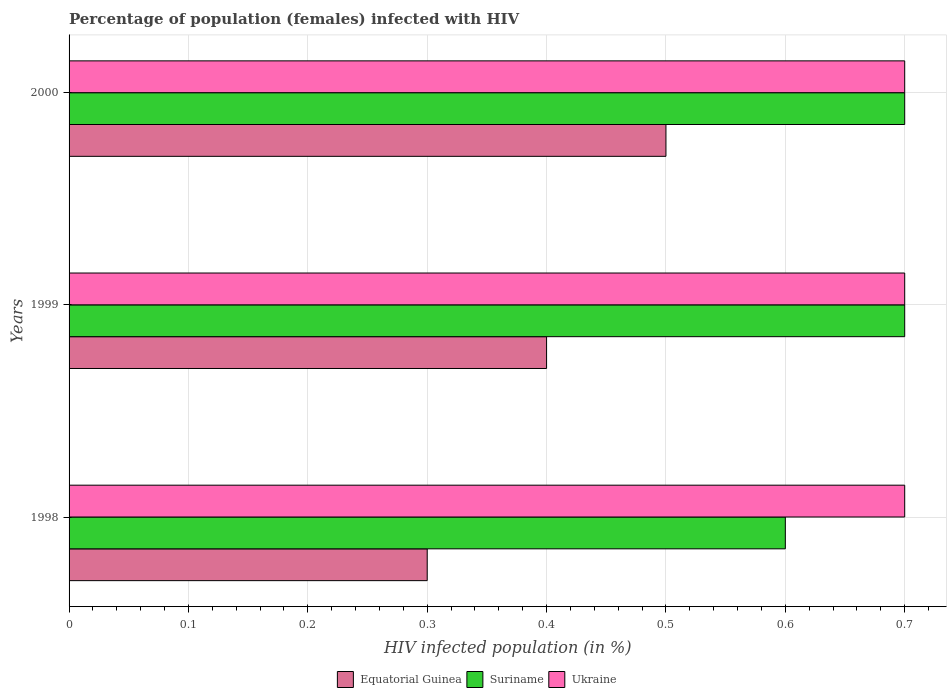How many different coloured bars are there?
Ensure brevity in your answer.  3. How many groups of bars are there?
Offer a very short reply. 3. Are the number of bars on each tick of the Y-axis equal?
Give a very brief answer. Yes. What is the label of the 1st group of bars from the top?
Your answer should be very brief. 2000. In how many cases, is the number of bars for a given year not equal to the number of legend labels?
Offer a very short reply. 0. What is the percentage of HIV infected female population in Ukraine in 2000?
Your answer should be compact. 0.7. Across all years, what is the maximum percentage of HIV infected female population in Ukraine?
Provide a short and direct response. 0.7. In which year was the percentage of HIV infected female population in Equatorial Guinea maximum?
Make the answer very short. 2000. What is the total percentage of HIV infected female population in Suriname in the graph?
Your answer should be compact. 2. What is the difference between the percentage of HIV infected female population in Equatorial Guinea in 1999 and that in 2000?
Your answer should be compact. -0.1. What is the average percentage of HIV infected female population in Suriname per year?
Provide a succinct answer. 0.67. In the year 1998, what is the difference between the percentage of HIV infected female population in Equatorial Guinea and percentage of HIV infected female population in Suriname?
Provide a short and direct response. -0.3. What is the ratio of the percentage of HIV infected female population in Equatorial Guinea in 1998 to that in 1999?
Keep it short and to the point. 0.75. What is the difference between the highest and the second highest percentage of HIV infected female population in Equatorial Guinea?
Provide a short and direct response. 0.1. What is the difference between the highest and the lowest percentage of HIV infected female population in Suriname?
Make the answer very short. 0.1. What does the 1st bar from the top in 1998 represents?
Ensure brevity in your answer.  Ukraine. What does the 1st bar from the bottom in 2000 represents?
Your answer should be very brief. Equatorial Guinea. Are all the bars in the graph horizontal?
Provide a succinct answer. Yes. How many years are there in the graph?
Offer a very short reply. 3. Does the graph contain grids?
Your answer should be compact. Yes. Where does the legend appear in the graph?
Your answer should be very brief. Bottom center. How many legend labels are there?
Keep it short and to the point. 3. What is the title of the graph?
Offer a very short reply. Percentage of population (females) infected with HIV. Does "Mali" appear as one of the legend labels in the graph?
Give a very brief answer. No. What is the label or title of the X-axis?
Make the answer very short. HIV infected population (in %). What is the HIV infected population (in %) of Ukraine in 1998?
Your response must be concise. 0.7. What is the HIV infected population (in %) of Equatorial Guinea in 1999?
Keep it short and to the point. 0.4. What is the HIV infected population (in %) in Suriname in 1999?
Make the answer very short. 0.7. What is the HIV infected population (in %) of Equatorial Guinea in 2000?
Ensure brevity in your answer.  0.5. What is the HIV infected population (in %) in Suriname in 2000?
Give a very brief answer. 0.7. Across all years, what is the minimum HIV infected population (in %) in Equatorial Guinea?
Keep it short and to the point. 0.3. Across all years, what is the minimum HIV infected population (in %) of Suriname?
Your response must be concise. 0.6. Across all years, what is the minimum HIV infected population (in %) in Ukraine?
Your answer should be very brief. 0.7. What is the difference between the HIV infected population (in %) of Equatorial Guinea in 1998 and that in 1999?
Ensure brevity in your answer.  -0.1. What is the difference between the HIV infected population (in %) in Ukraine in 1998 and that in 1999?
Give a very brief answer. 0. What is the difference between the HIV infected population (in %) in Equatorial Guinea in 1998 and that in 2000?
Your response must be concise. -0.2. What is the difference between the HIV infected population (in %) of Ukraine in 1998 and that in 2000?
Your answer should be very brief. 0. What is the difference between the HIV infected population (in %) in Equatorial Guinea in 1999 and the HIV infected population (in %) in Ukraine in 2000?
Offer a terse response. -0.3. What is the average HIV infected population (in %) in Equatorial Guinea per year?
Offer a terse response. 0.4. In the year 1998, what is the difference between the HIV infected population (in %) of Equatorial Guinea and HIV infected population (in %) of Suriname?
Ensure brevity in your answer.  -0.3. In the year 1998, what is the difference between the HIV infected population (in %) of Suriname and HIV infected population (in %) of Ukraine?
Keep it short and to the point. -0.1. In the year 1999, what is the difference between the HIV infected population (in %) in Equatorial Guinea and HIV infected population (in %) in Ukraine?
Ensure brevity in your answer.  -0.3. In the year 2000, what is the difference between the HIV infected population (in %) in Equatorial Guinea and HIV infected population (in %) in Suriname?
Your response must be concise. -0.2. What is the ratio of the HIV infected population (in %) of Ukraine in 1998 to that in 1999?
Offer a terse response. 1. What is the ratio of the HIV infected population (in %) of Equatorial Guinea in 1998 to that in 2000?
Make the answer very short. 0.6. What is the ratio of the HIV infected population (in %) of Ukraine in 1998 to that in 2000?
Provide a short and direct response. 1. What is the ratio of the HIV infected population (in %) of Equatorial Guinea in 1999 to that in 2000?
Your response must be concise. 0.8. What is the difference between the highest and the second highest HIV infected population (in %) of Suriname?
Your answer should be very brief. 0. What is the difference between the highest and the lowest HIV infected population (in %) in Equatorial Guinea?
Make the answer very short. 0.2. What is the difference between the highest and the lowest HIV infected population (in %) of Suriname?
Offer a very short reply. 0.1. 